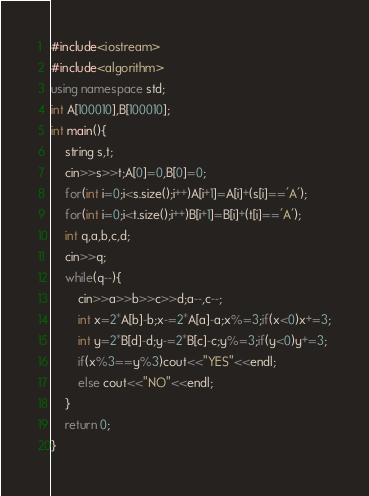Convert code to text. <code><loc_0><loc_0><loc_500><loc_500><_C++_>#include<iostream>
#include<algorithm>
using namespace std;
int A[100010],B[100010];
int main(){
	string s,t;
	cin>>s>>t;A[0]=0,B[0]=0;
	for(int i=0;i<s.size();i++)A[i+1]=A[i]+(s[i]=='A');
	for(int i=0;i<t.size();i++)B[i+1]=B[i]+(t[i]=='A');
	int q,a,b,c,d;
	cin>>q;
	while(q--){
		cin>>a>>b>>c>>d;a--,c--;
		int x=2*A[b]-b;x-=2*A[a]-a;x%=3;if(x<0)x+=3;
		int y=2*B[d]-d;y-=2*B[c]-c;y%=3;if(y<0)y+=3;
		if(x%3==y%3)cout<<"YES"<<endl;
		else cout<<"NO"<<endl;
	}
	return 0;
}
</code> 